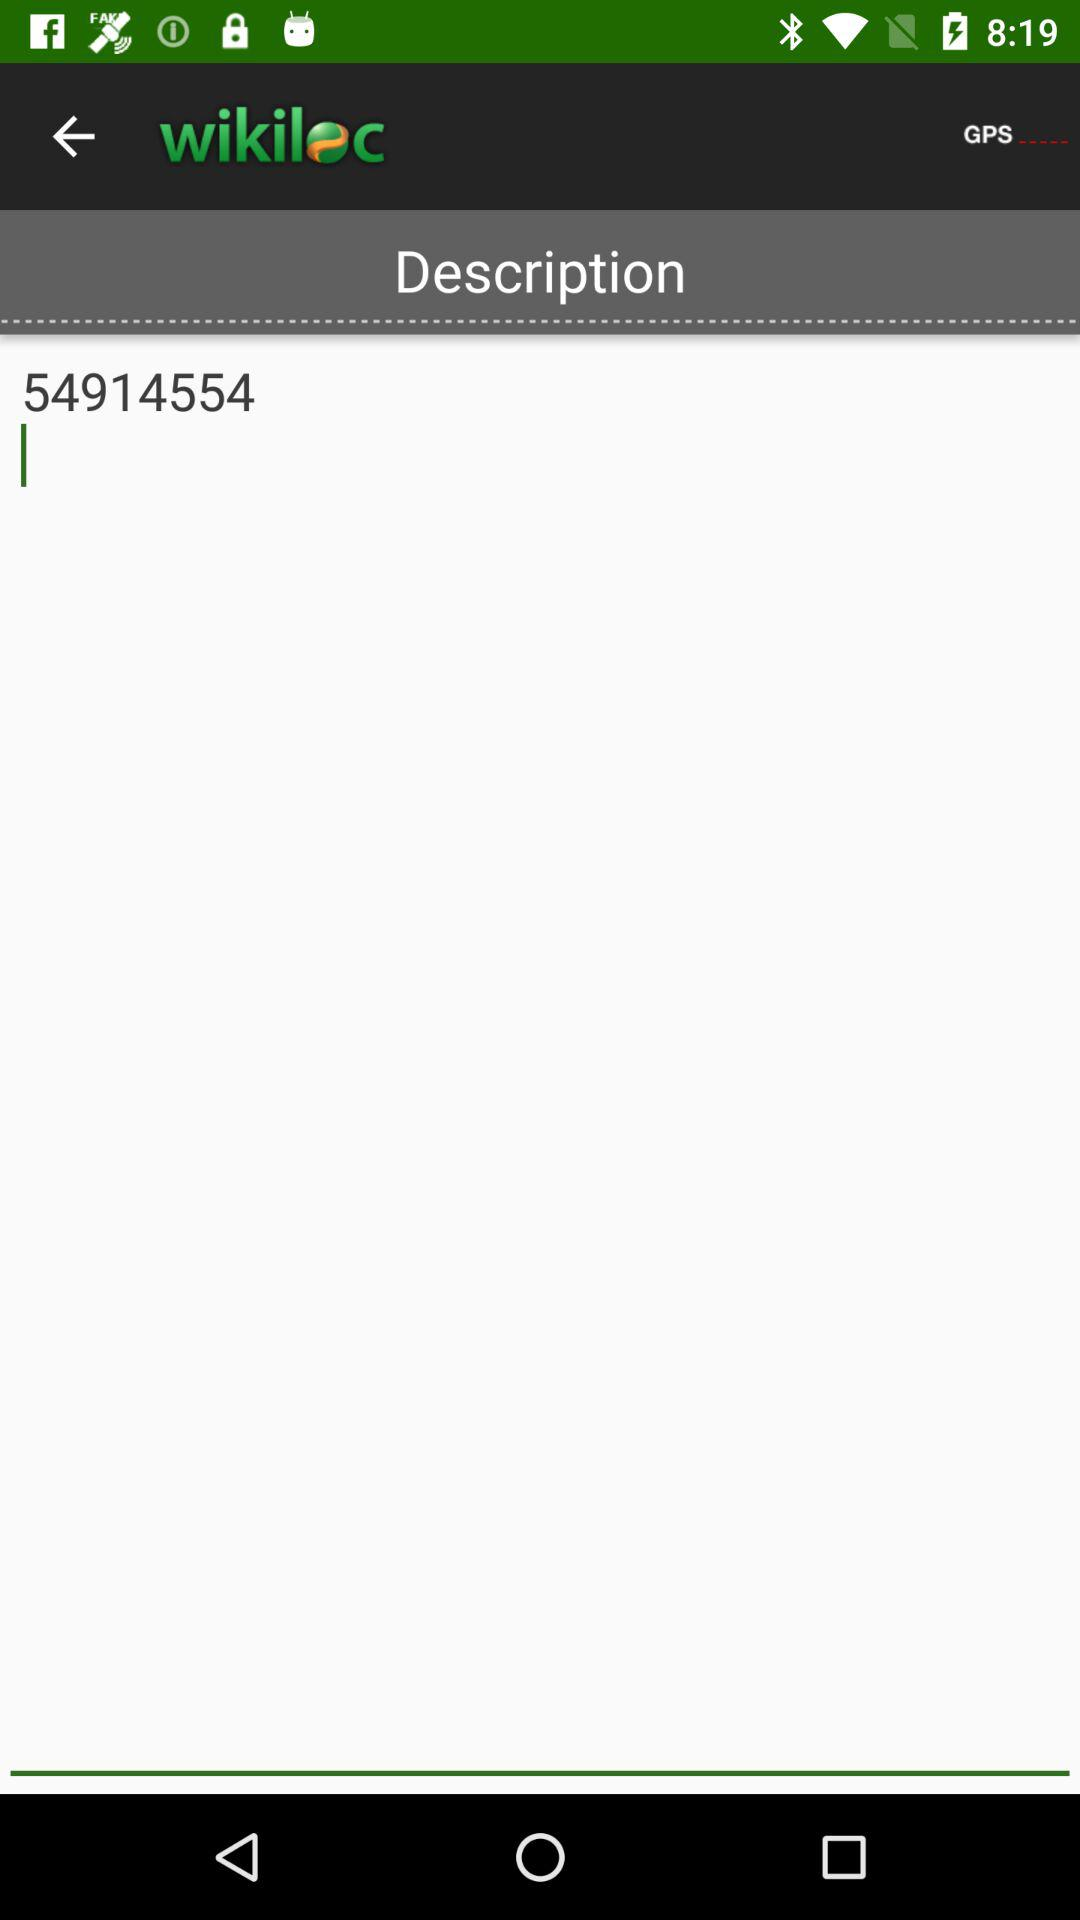What is the GPS location?
When the provided information is insufficient, respond with <no answer>. <no answer> 